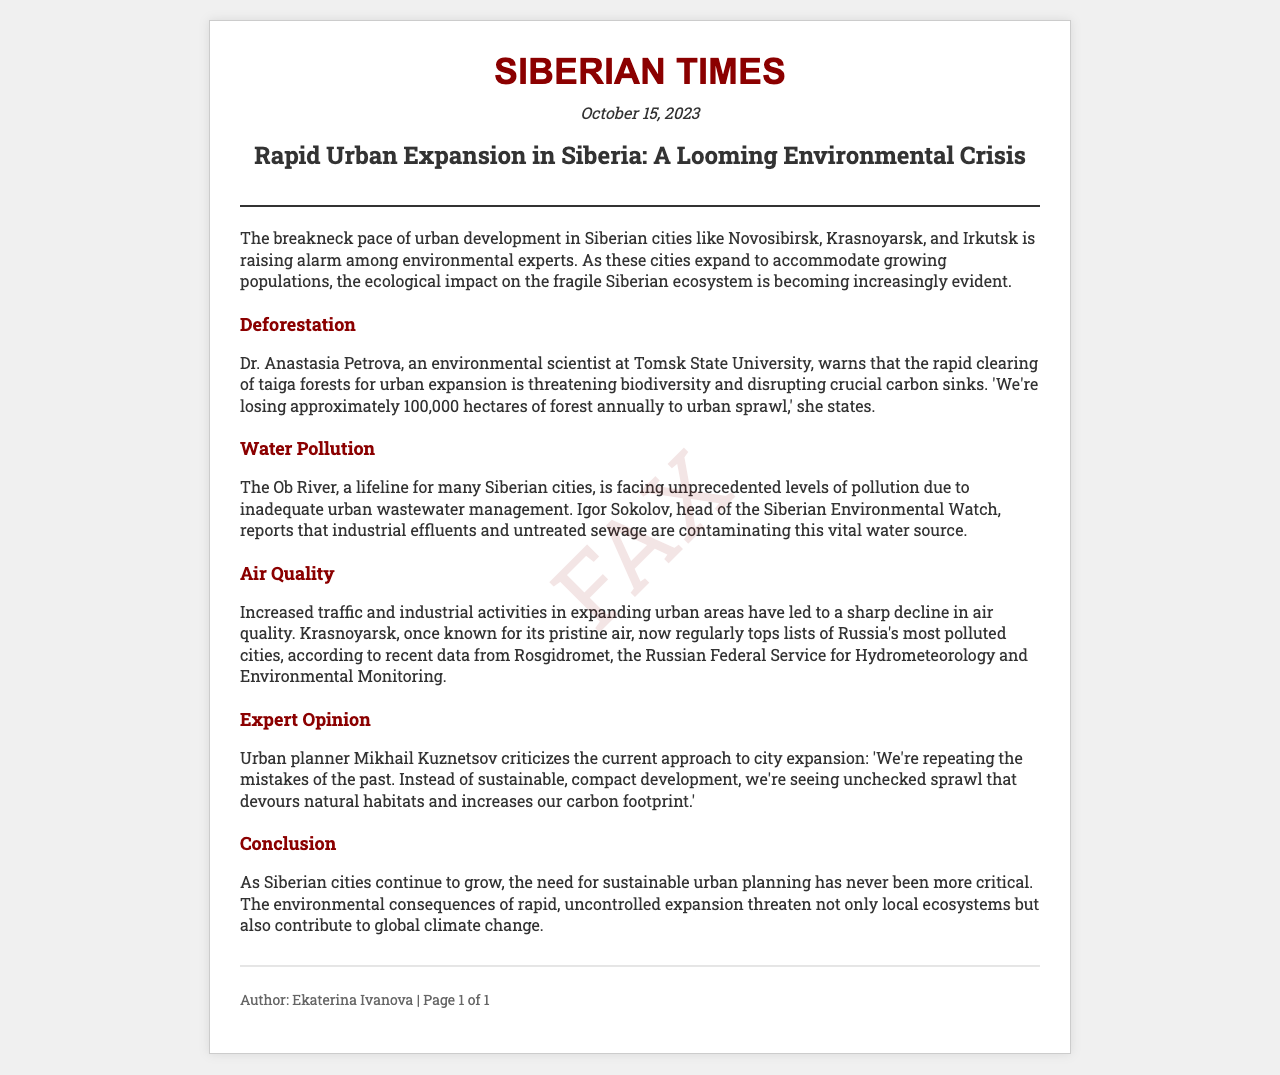what is the title of the article? The title is stated at the top of the document, following the headline format.
Answer: Rapid Urban Expansion in Siberia: A Looming Environmental Crisis who is the author of the article? The author's name is provided in the footer section of the document.
Answer: Ekaterina Ivanova what is the date of the article? The date is prominently displayed in the document to indicate when it was published.
Answer: October 15, 2023 how many hectares of forest are lost annually due to urban sprawl? The document quotes Dr. Anastasia Petrova on the amount of forest lost.
Answer: 100,000 hectares which river is mentioned as facing pollution? The river is highlighted in the water pollution section of the article.
Answer: Ob River who warns about pollution in the Ob River? The section mentions an individual responsible for raising awareness about this issue.
Answer: Igor Sokolov which city is reported as having a sharp decline in air quality? The document lists cities with declining air quality under the air quality section.
Answer: Krasnoyarsk what did urban planner Mikhail Kuznetsov criticize? The criticism focuses on the approach to urban planning as described in the expert opinion section.
Answer: Unchecked sprawl what is the main concern expressed in the conclusion? The conclusion summarizes the overarching theme of the urgent need for sustainable development.
Answer: Sustainable urban planning is critical 